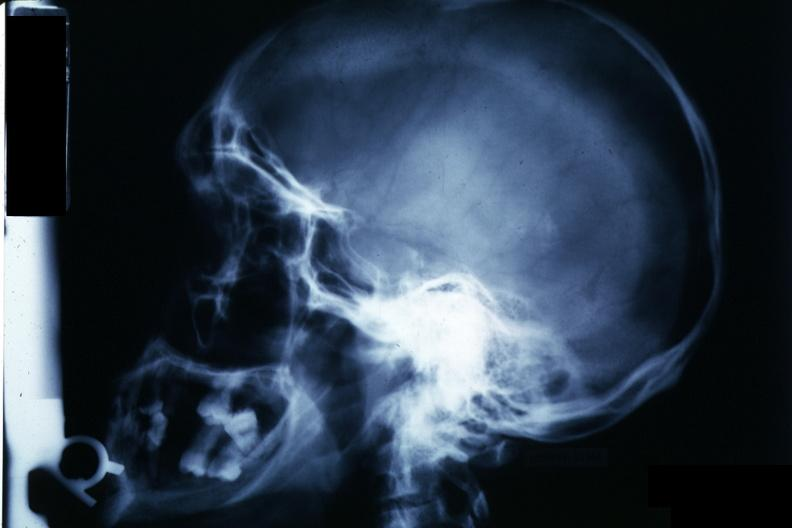where does this x-ray been taken?
Answer the question using a single word or phrase. Endocrine system 